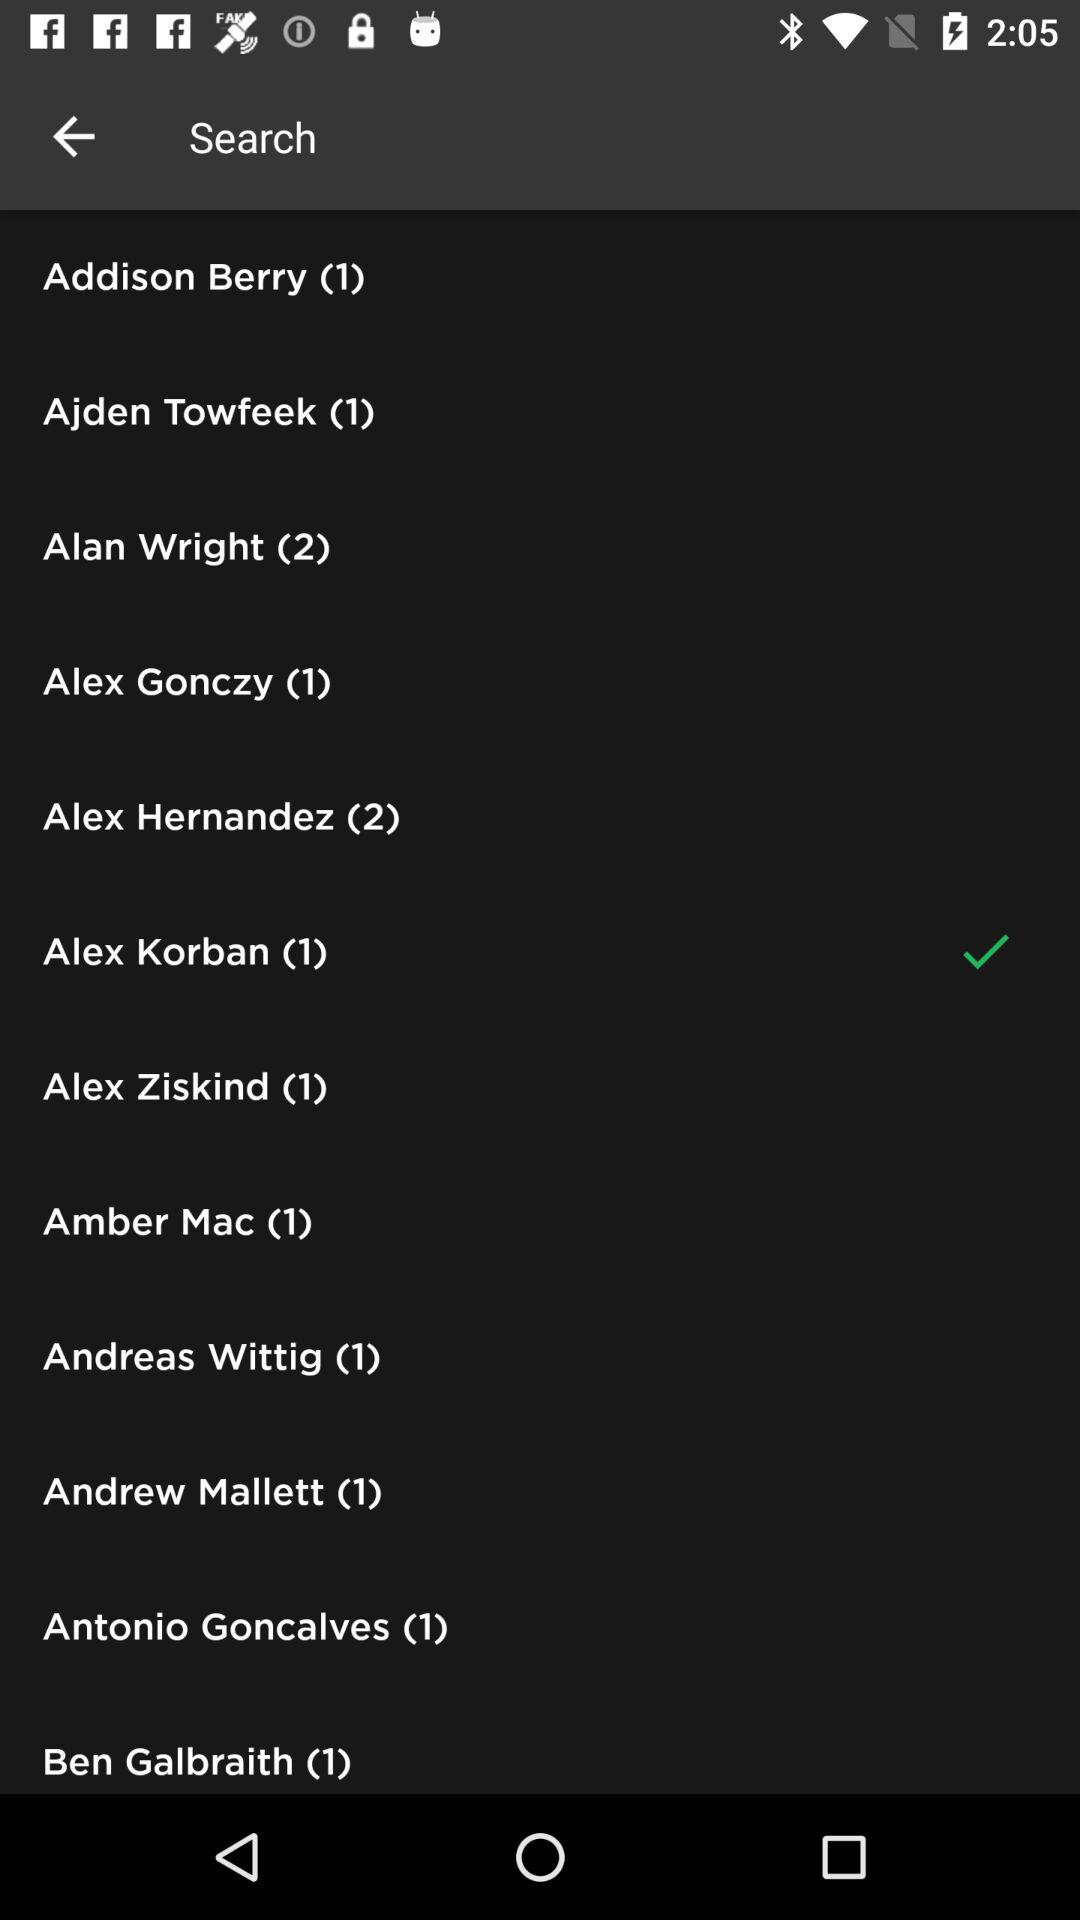Which option is selected? The selected option is "Alex Korban (1)". 